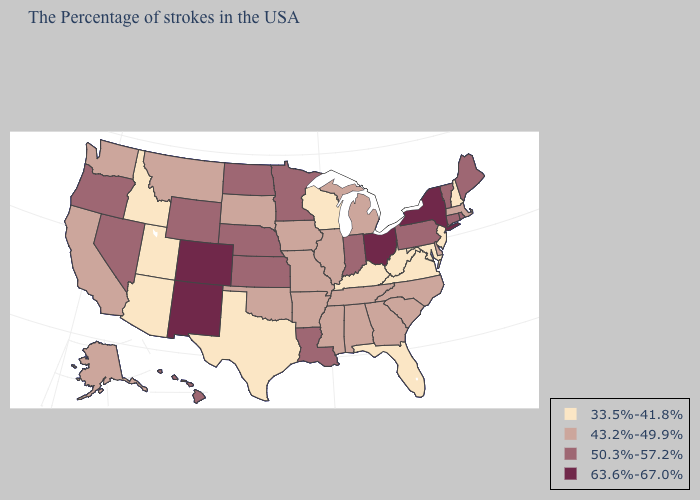What is the value of Wisconsin?
Concise answer only. 33.5%-41.8%. What is the lowest value in the USA?
Answer briefly. 33.5%-41.8%. Which states have the lowest value in the MidWest?
Quick response, please. Wisconsin. What is the value of Nevada?
Write a very short answer. 50.3%-57.2%. Name the states that have a value in the range 63.6%-67.0%?
Give a very brief answer. New York, Ohio, Colorado, New Mexico. Among the states that border Illinois , which have the highest value?
Be succinct. Indiana. How many symbols are there in the legend?
Short answer required. 4. Among the states that border Michigan , which have the lowest value?
Write a very short answer. Wisconsin. Does Colorado have a lower value than Virginia?
Short answer required. No. Does the map have missing data?
Answer briefly. No. Does Ohio have the highest value in the USA?
Write a very short answer. Yes. What is the value of Arkansas?
Answer briefly. 43.2%-49.9%. Name the states that have a value in the range 43.2%-49.9%?
Short answer required. Massachusetts, Delaware, North Carolina, South Carolina, Georgia, Michigan, Alabama, Tennessee, Illinois, Mississippi, Missouri, Arkansas, Iowa, Oklahoma, South Dakota, Montana, California, Washington, Alaska. Does Utah have the lowest value in the West?
Short answer required. Yes. Name the states that have a value in the range 50.3%-57.2%?
Concise answer only. Maine, Rhode Island, Vermont, Connecticut, Pennsylvania, Indiana, Louisiana, Minnesota, Kansas, Nebraska, North Dakota, Wyoming, Nevada, Oregon, Hawaii. 